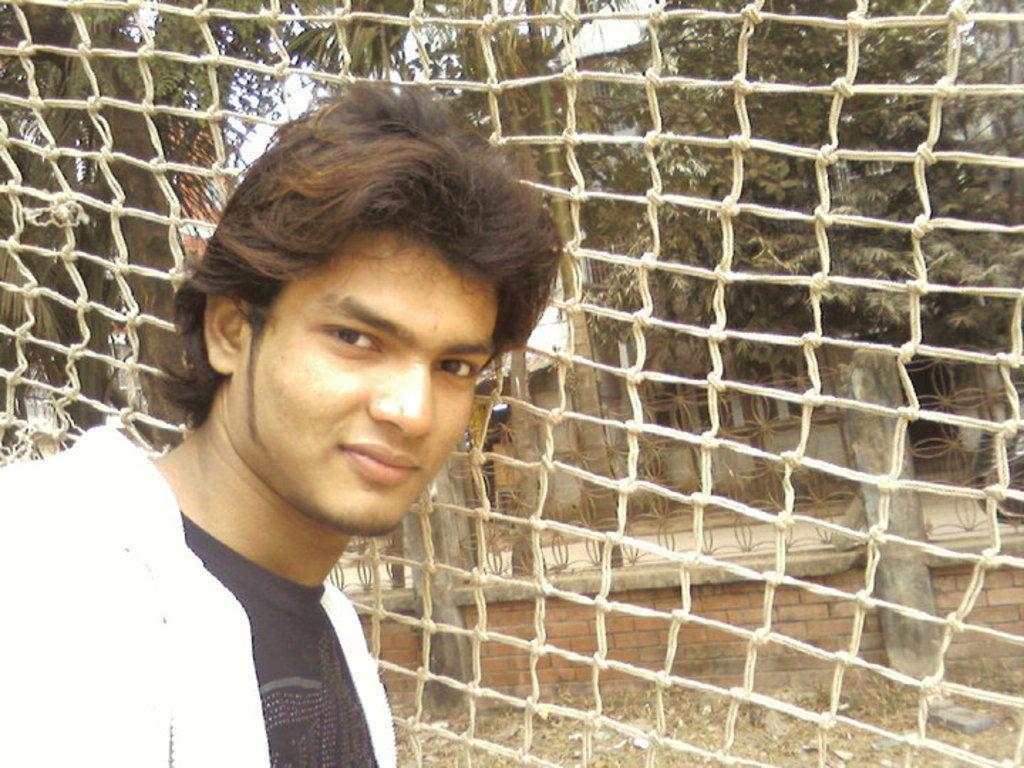Could you give a brief overview of what you see in this image? In this picture we can see a man is standing on the path. Behind the man there is a net, trees, houses and a sky. 